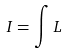Convert formula to latex. <formula><loc_0><loc_0><loc_500><loc_500>I = \int L</formula> 